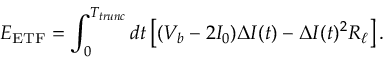Convert formula to latex. <formula><loc_0><loc_0><loc_500><loc_500>E _ { E T F } = \int _ { 0 } ^ { T _ { t r u n c } } d t \left [ ( V _ { b } - 2 I _ { 0 } ) \Delta I ( t ) - \Delta I ( t ) ^ { 2 } R _ { \ell } \right ] .</formula> 